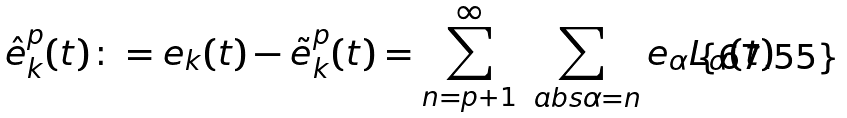Convert formula to latex. <formula><loc_0><loc_0><loc_500><loc_500>\hat { e } _ { k } ^ { p } ( t ) \colon = e _ { k } ( t ) - \tilde { e } _ { k } ^ { p } ( t ) = \sum _ { n = p + 1 } ^ { \infty } \sum _ { \ a b s { \alpha } = n } e _ { \alpha } L _ { \alpha } ( t )</formula> 